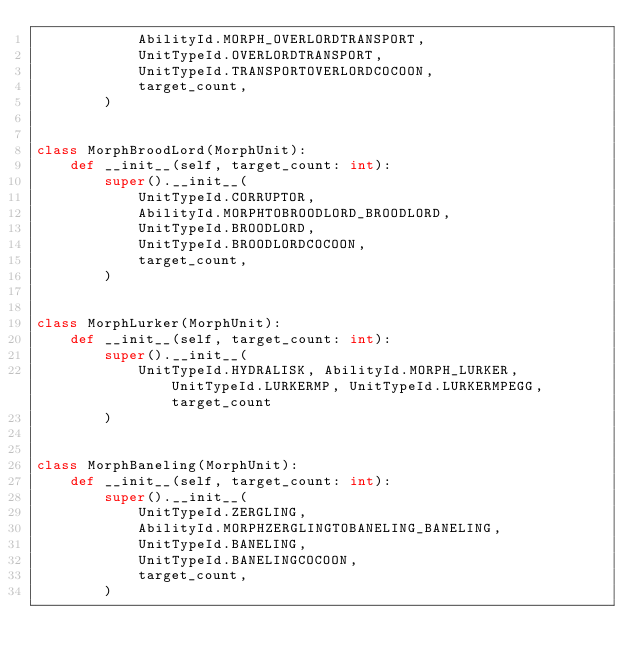Convert code to text. <code><loc_0><loc_0><loc_500><loc_500><_Python_>            AbilityId.MORPH_OVERLORDTRANSPORT,
            UnitTypeId.OVERLORDTRANSPORT,
            UnitTypeId.TRANSPORTOVERLORDCOCOON,
            target_count,
        )


class MorphBroodLord(MorphUnit):
    def __init__(self, target_count: int):
        super().__init__(
            UnitTypeId.CORRUPTOR,
            AbilityId.MORPHTOBROODLORD_BROODLORD,
            UnitTypeId.BROODLORD,
            UnitTypeId.BROODLORDCOCOON,
            target_count,
        )


class MorphLurker(MorphUnit):
    def __init__(self, target_count: int):
        super().__init__(
            UnitTypeId.HYDRALISK, AbilityId.MORPH_LURKER, UnitTypeId.LURKERMP, UnitTypeId.LURKERMPEGG, target_count
        )


class MorphBaneling(MorphUnit):
    def __init__(self, target_count: int):
        super().__init__(
            UnitTypeId.ZERGLING,
            AbilityId.MORPHZERGLINGTOBANELING_BANELING,
            UnitTypeId.BANELING,
            UnitTypeId.BANELINGCOCOON,
            target_count,
        )
</code> 